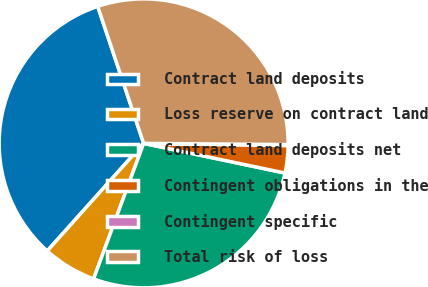Convert chart. <chart><loc_0><loc_0><loc_500><loc_500><pie_chart><fcel>Contract land deposits<fcel>Loss reserve on contract land<fcel>Contract land deposits net<fcel>Contingent obligations in the<fcel>Contingent specific<fcel>Total risk of loss<nl><fcel>33.22%<fcel>6.0%<fcel>27.33%<fcel>3.05%<fcel>0.11%<fcel>30.28%<nl></chart> 